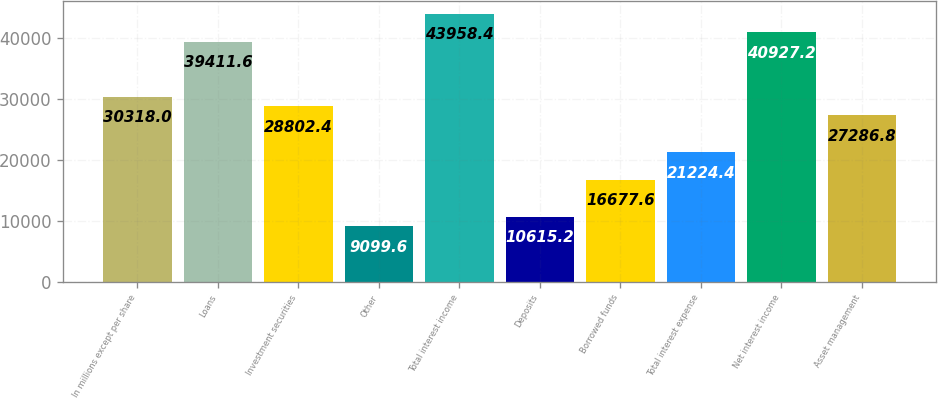<chart> <loc_0><loc_0><loc_500><loc_500><bar_chart><fcel>In millions except per share<fcel>Loans<fcel>Investment securities<fcel>Other<fcel>Total interest income<fcel>Deposits<fcel>Borrowed funds<fcel>Total interest expense<fcel>Net interest income<fcel>Asset management<nl><fcel>30318<fcel>39411.6<fcel>28802.4<fcel>9099.6<fcel>43958.4<fcel>10615.2<fcel>16677.6<fcel>21224.4<fcel>40927.2<fcel>27286.8<nl></chart> 